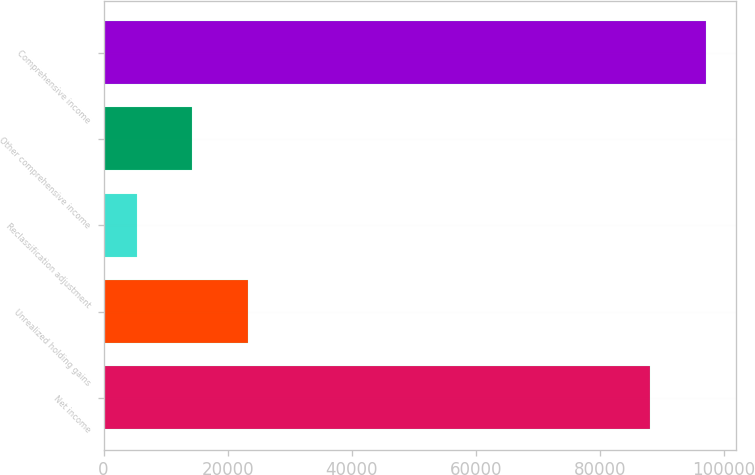Convert chart. <chart><loc_0><loc_0><loc_500><loc_500><bar_chart><fcel>Net income<fcel>Unrealized holding gains<fcel>Reclassification adjustment<fcel>Other comprehensive income<fcel>Comprehensive income<nl><fcel>88154<fcel>23304.2<fcel>5323<fcel>14313.6<fcel>97144.6<nl></chart> 